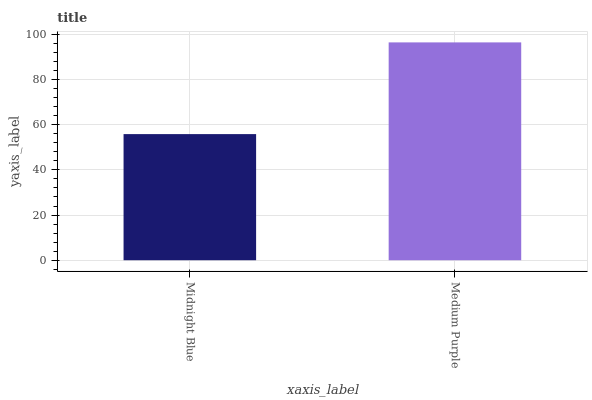Is Medium Purple the minimum?
Answer yes or no. No. Is Medium Purple greater than Midnight Blue?
Answer yes or no. Yes. Is Midnight Blue less than Medium Purple?
Answer yes or no. Yes. Is Midnight Blue greater than Medium Purple?
Answer yes or no. No. Is Medium Purple less than Midnight Blue?
Answer yes or no. No. Is Medium Purple the high median?
Answer yes or no. Yes. Is Midnight Blue the low median?
Answer yes or no. Yes. Is Midnight Blue the high median?
Answer yes or no. No. Is Medium Purple the low median?
Answer yes or no. No. 